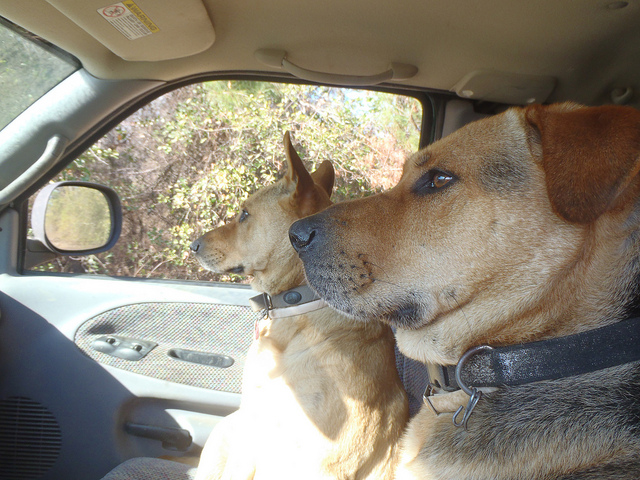What breed do the dogs appear to be? The dogs resemble mixed breeds, with features that are not distinctly characteristic of a specific breed, but one of them appears to have traits similar to a Labrador Retriever. 